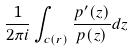Convert formula to latex. <formula><loc_0><loc_0><loc_500><loc_500>\frac { 1 } { 2 \pi i } \int _ { c ( r ) } \frac { p ^ { \prime } ( z ) } { p ( z ) } d z</formula> 